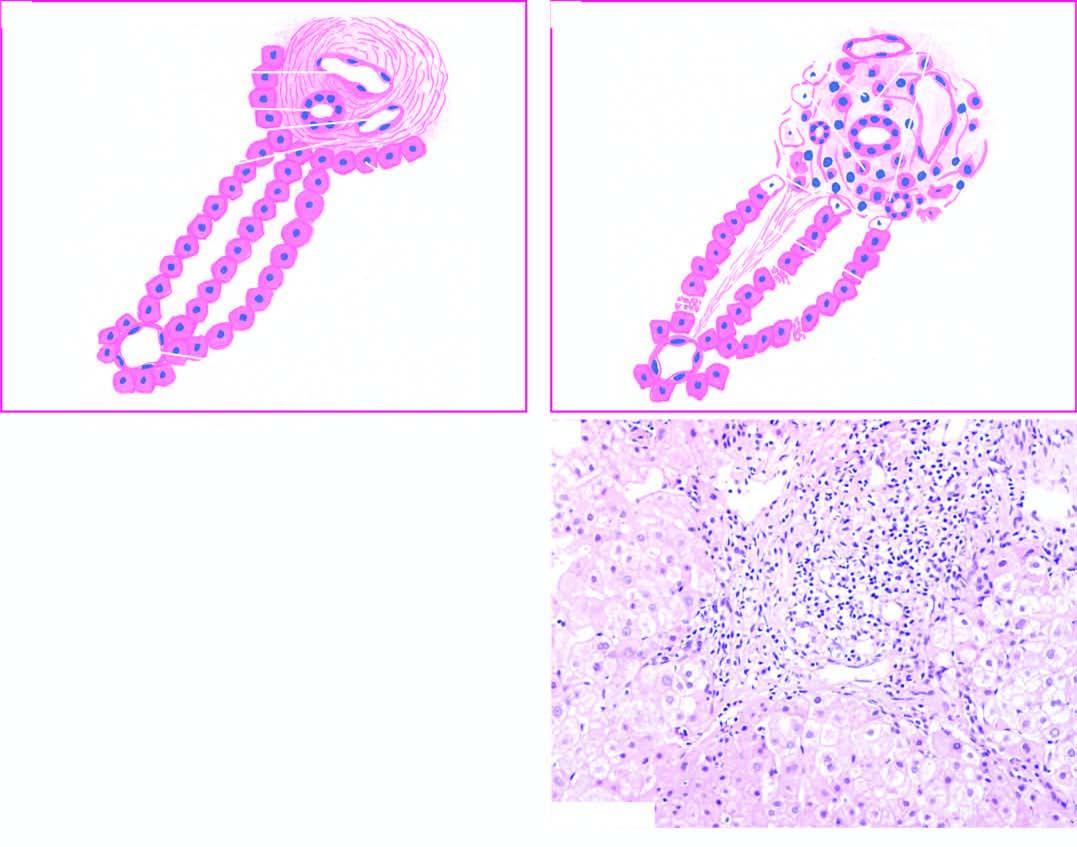what is the portal tract expanded due to?
Answer the question using a single word or phrase. Increased lymphomononuclear inflammatory cells 